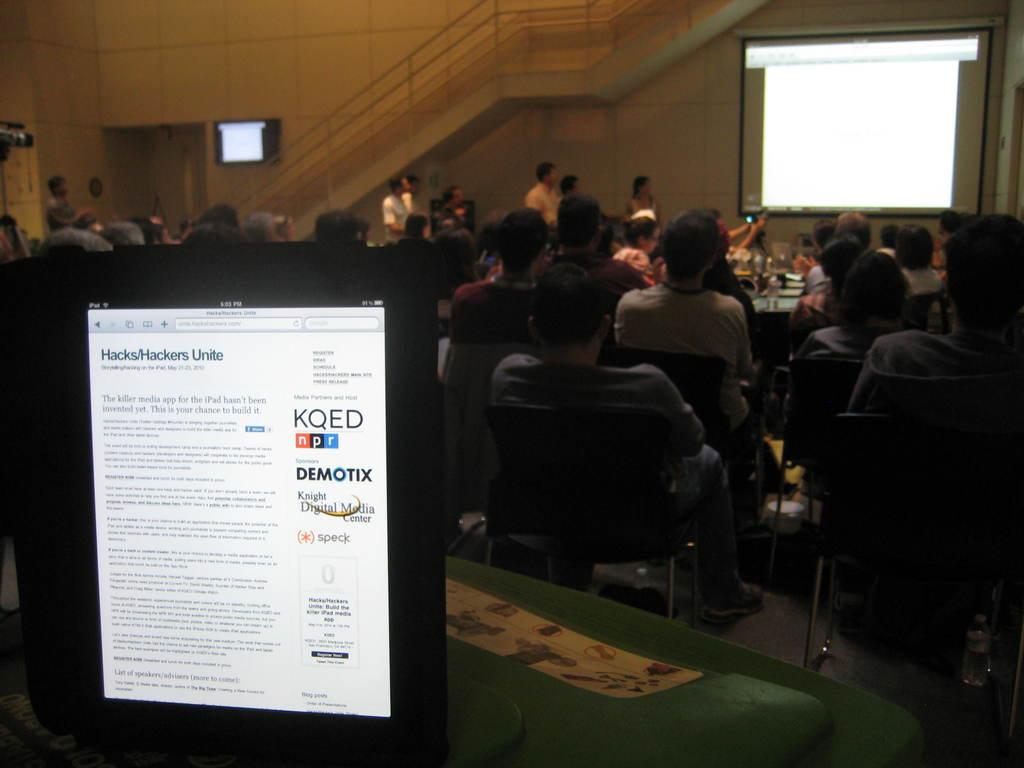Who or what can be seen in the image? There are people in the image. What is the primary object or furniture in the image? There is a table in the image. What type of electronic device is present in the image? There is a screen in the image. What architectural feature is visible in the image? There are stairs in the image. What structural element is present in the image? There is a wall in the image. What month is it in the image? The month cannot be determined from the image, as it does not contain any information about the time or date. 